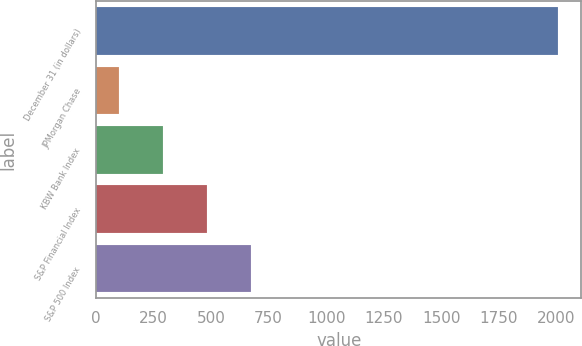Convert chart to OTSL. <chart><loc_0><loc_0><loc_500><loc_500><bar_chart><fcel>December 31 (in dollars)<fcel>JPMorgan Chase<fcel>KBW Bank Index<fcel>S&P Financial Index<fcel>S&P 500 Index<nl><fcel>2009<fcel>100<fcel>290.9<fcel>481.8<fcel>672.7<nl></chart> 